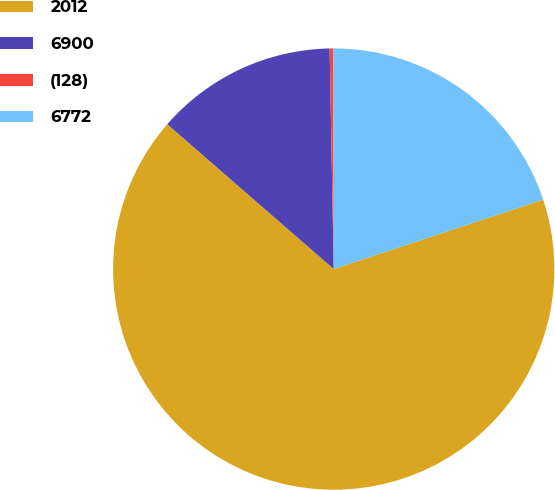Convert chart. <chart><loc_0><loc_0><loc_500><loc_500><pie_chart><fcel>2012<fcel>6900<fcel>(128)<fcel>6772<nl><fcel>66.49%<fcel>13.31%<fcel>0.27%<fcel>19.93%<nl></chart> 